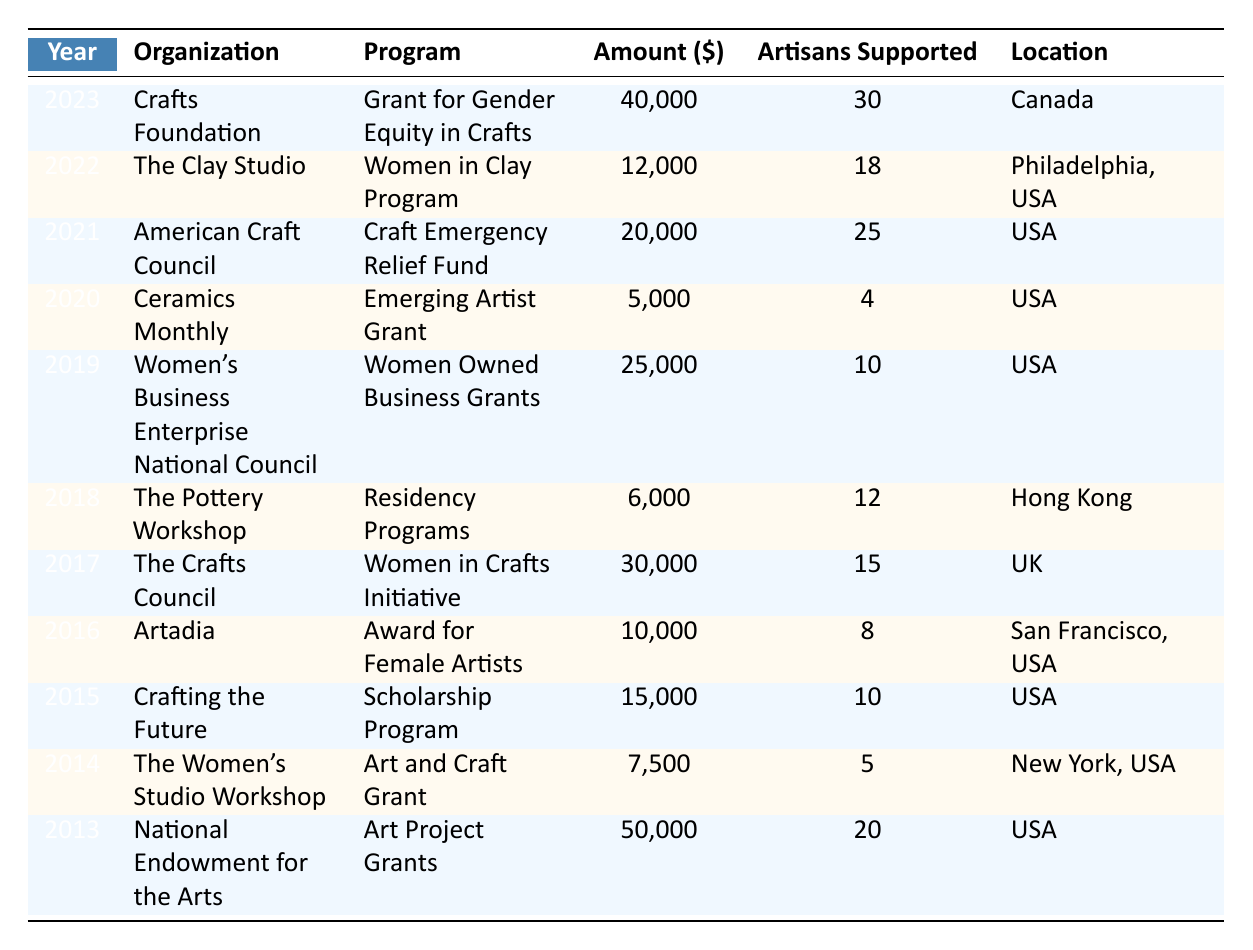What was the highest funding amount for female artisans in the pottery industry? The maximum value in the "Amount" column is 50,000, which corresponds to the year 2013 from the National Endowment for the Arts.
Answer: 50,000 How many female artisans were supported in total over the years shown? Summing up the "Artisans Supported" column: 20 + 5 + 10 + 8 + 15 + 12 + 10 + 4 + 25 + 18 + 30 =  5. Adding these numbers gives a total of 20 + 5 + 10 + 8 + 15 + 12 + 10 + 4 + 25 + 18 + 30 =  15 + 12 + 10 + 4 + 25 + 18 + 30 = 152.
Answer: 152 Which organization provided support for the most female artisans in a single year? The largest number of female artisans supported in one year is 30 in 2023 by the Crafts Foundation.
Answer: Crafts Foundation What is the average amount of funding provided to female artisans per year from 2013 to 2023? To find the average, first calculate the total funding: 50,000 + 7,500 + 15,000 + 10,000 + 30,000 + 6,000 + 25,000 + 5,000 + 20,000 + 12,000 + 40,000 =  6. Then divide by the number of years (11), so total is 50,000 + 7,500 + 15,000 + 10,000 + 30,000 + 6,000 + 25,000 + 5,000 + 20,000 + 12,000 + 40,000 =  250,500. Hence, the average is 250,500 / 11 = 22,772.73.
Answer: 22,772.73 Was there an increase in funding for female artisans from 2020 to 2023? Funding in 2020 was 5,000, while in 2023 it was 40,000; indeed, this is an increase.
Answer: Yes What year had the least amount of funding for female artisans, and how much was it? The year with the least funding is 2020, which had an amount of 5,000.
Answer: 5,000 How many organizations provided funding support each year on average? Counting the number of entries, there are 11 organizations over 11 years, which gives an average of 1 organization per year.
Answer: 1 Was the Women in Crafts Initiative the only program specifically targeted at women artisans in crafts within the UK? Since there is only one entry from The Crafts Council in 2017 for Women in Crafts Initiative, it implies yes, therefore, it is the only listed program specifically in UK.
Answer: Yes In which year was the highest number of female artisans supported, and what was the funding amount for that year? The highest number of artisans supported was 30 in 2023 by the Crafts Foundation with an amount of 40,000.
Answer: 2023, 40,000 What percentage of total funding was allocated to the Crafts Council's program in 2017? The total funding is 250,500. The amount from the Crafts Council in 2017 was 30,000. Calculating the percentage: (30,000 / 250,500) * 100 = 11.97%.
Answer: 11.97% 